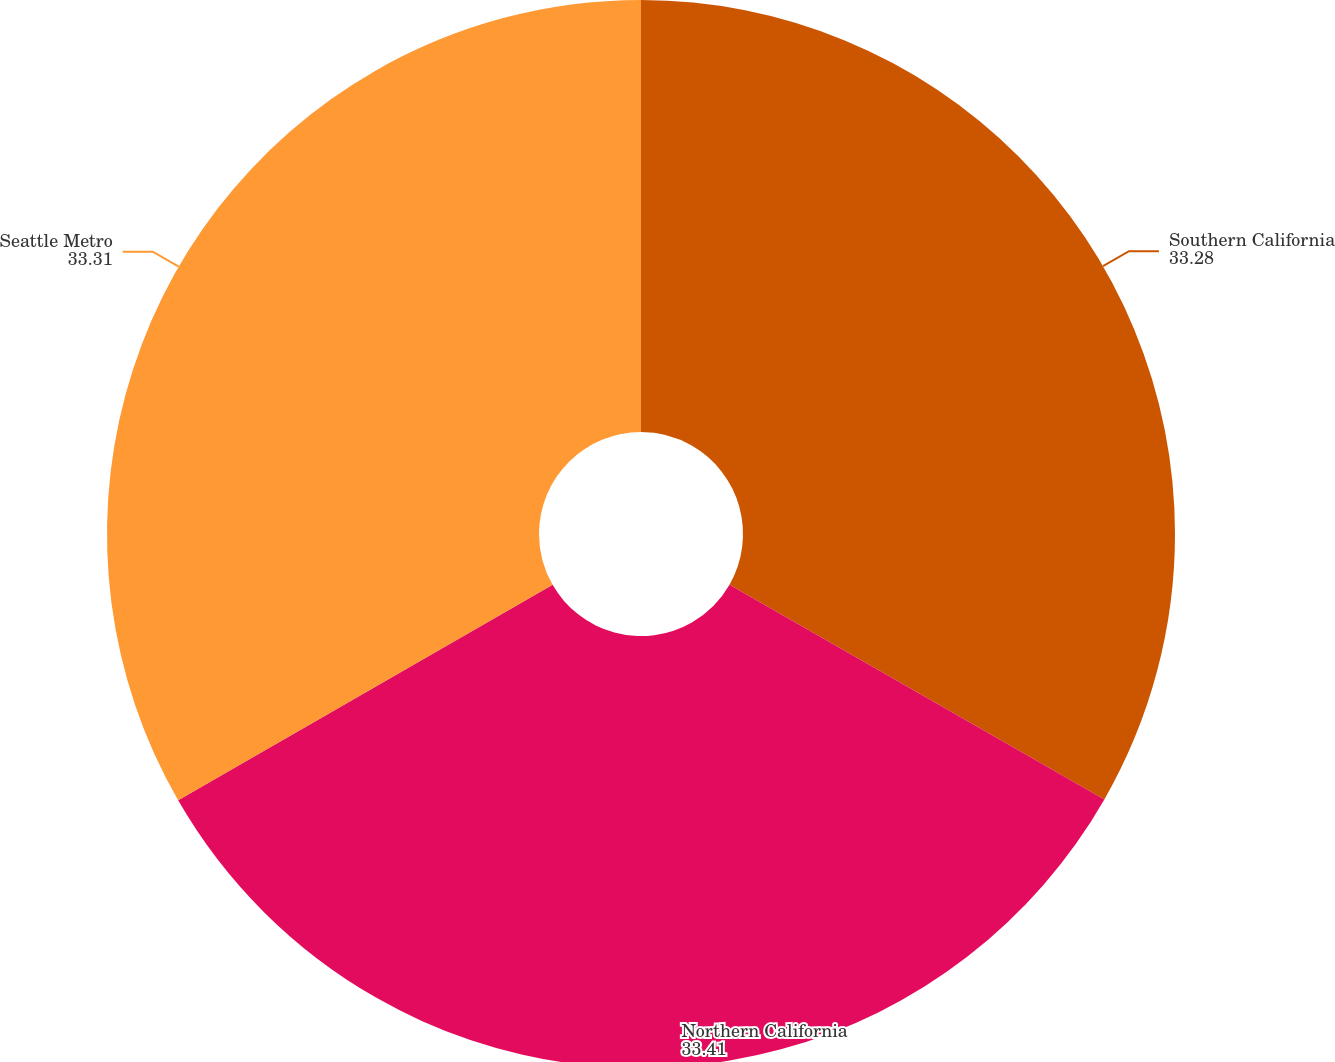Convert chart. <chart><loc_0><loc_0><loc_500><loc_500><pie_chart><fcel>Southern California<fcel>Northern California<fcel>Seattle Metro<nl><fcel>33.28%<fcel>33.41%<fcel>33.31%<nl></chart> 